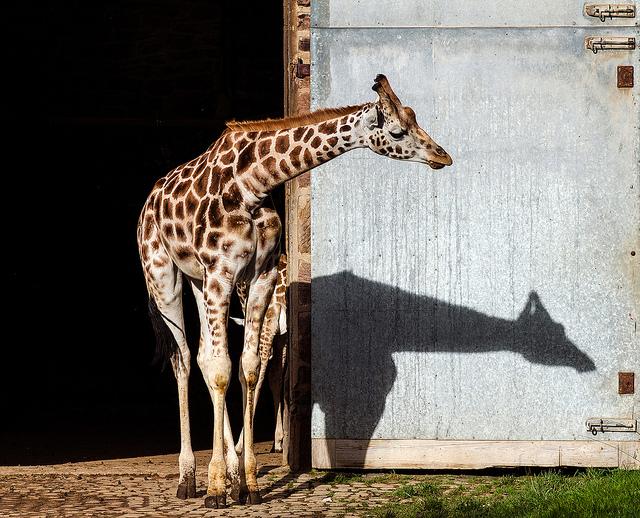How tall is the giraffe?
Concise answer only. 10 feet. What color is the giraffe?
Be succinct. Brown and white. Is the giraffe planning to go through this door?
Quick response, please. No. Is the animal jumping?
Answer briefly. No. Which direction is the giraffe facing?
Quick response, please. Right. 